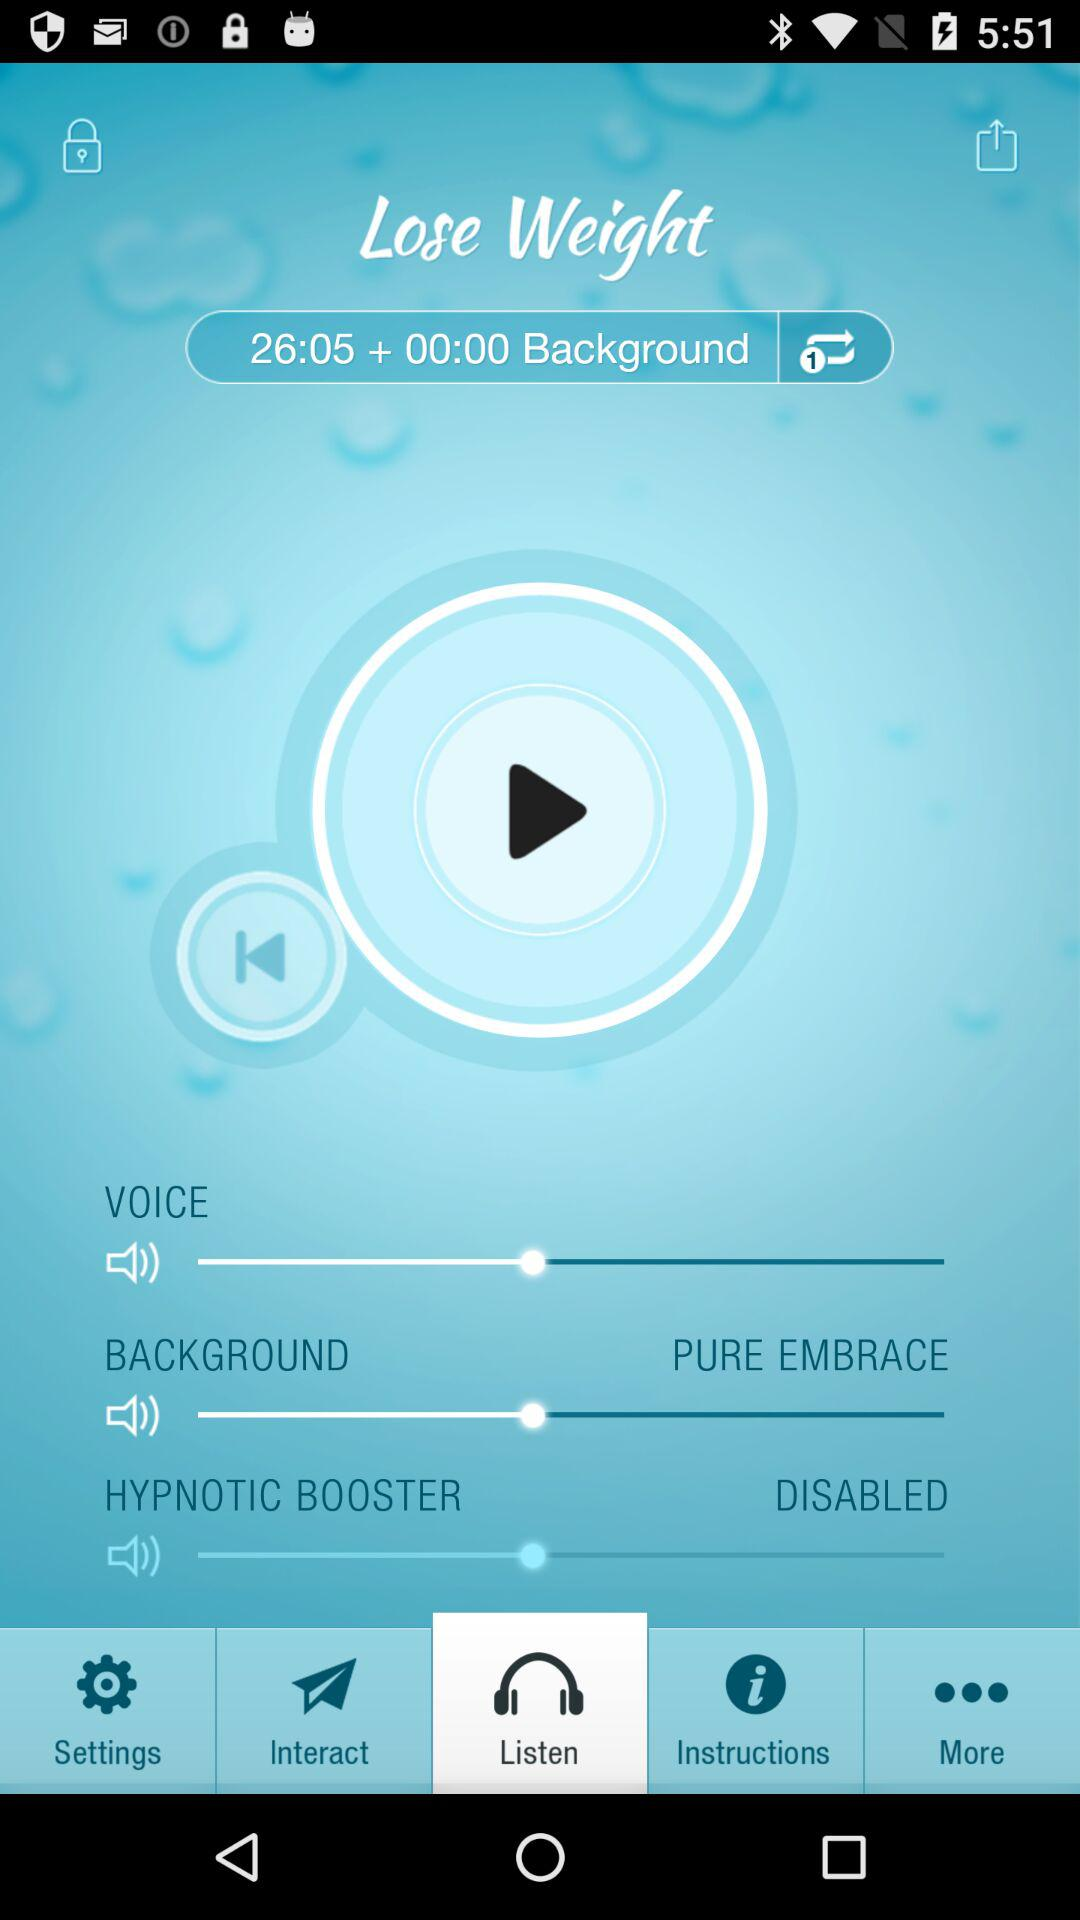What is the background given?
When the provided information is insufficient, respond with <no answer>. <no answer> 